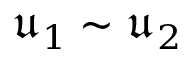Convert formula to latex. <formula><loc_0><loc_0><loc_500><loc_500>\mathfrak { u } _ { 1 } \sim \mathfrak { u } _ { 2 }</formula> 